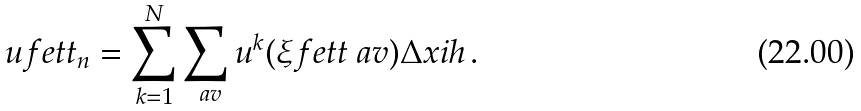<formula> <loc_0><loc_0><loc_500><loc_500>\ u f e t t _ { n } = \sum _ { k = 1 } ^ { N } \sum _ { \ a v } u ^ { k } ( \xi f e t t _ { \ } a v ) \Delta x i h \, .</formula> 